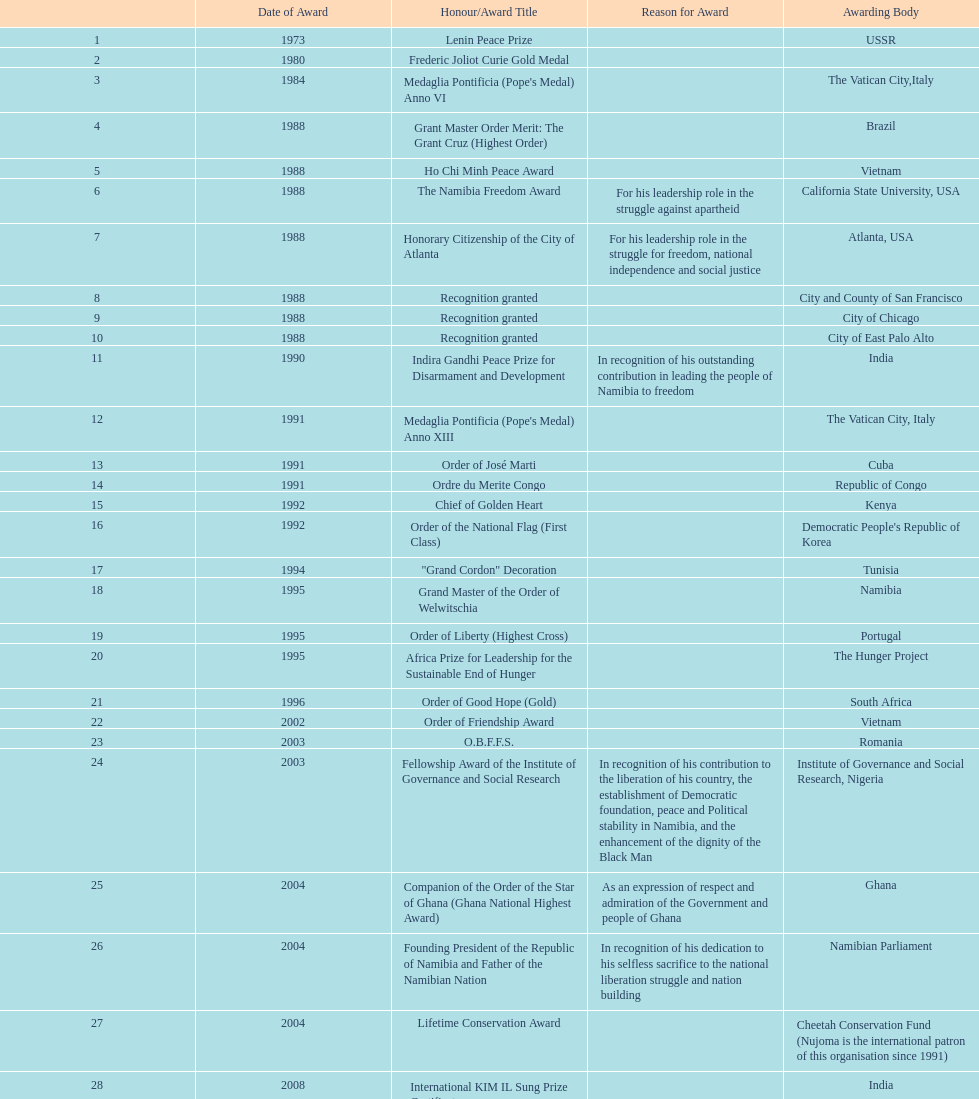According to this chart, how many total honors/award titles were mentioned? 29. 